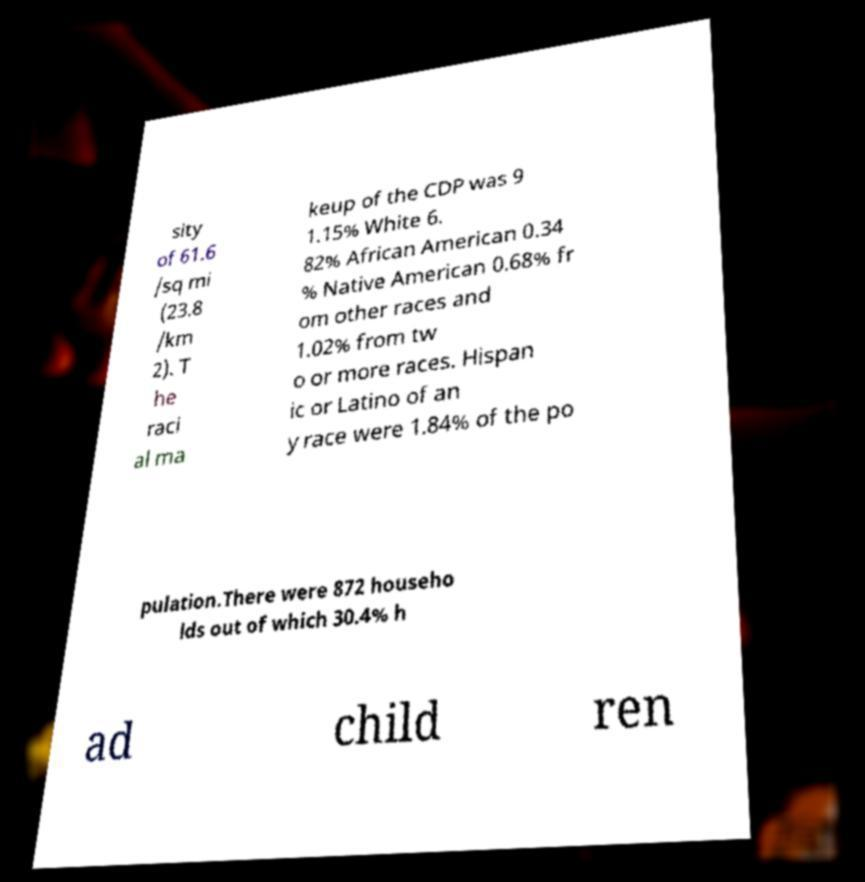For documentation purposes, I need the text within this image transcribed. Could you provide that? sity of 61.6 /sq mi (23.8 /km 2). T he raci al ma keup of the CDP was 9 1.15% White 6. 82% African American 0.34 % Native American 0.68% fr om other races and 1.02% from tw o or more races. Hispan ic or Latino of an y race were 1.84% of the po pulation.There were 872 househo lds out of which 30.4% h ad child ren 